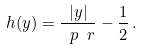<formula> <loc_0><loc_0><loc_500><loc_500>h ( y ) = \frac { | y | } { \ p \ r } - \frac { 1 } { 2 } \, .</formula> 